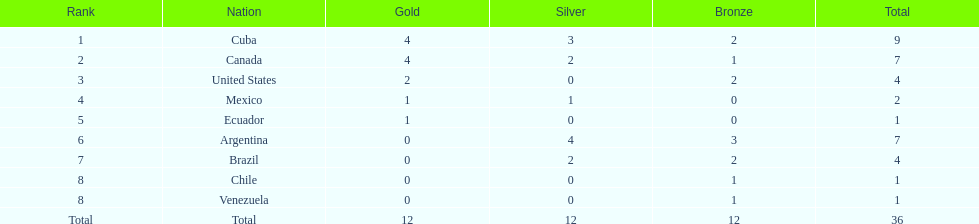What is the sum of all the medals together? 36. 